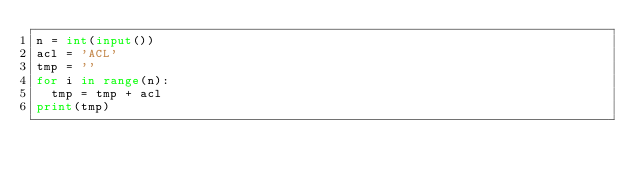Convert code to text. <code><loc_0><loc_0><loc_500><loc_500><_Python_>n = int(input())
acl = 'ACL'
tmp = ''
for i in range(n):
  tmp = tmp + acl
print(tmp)</code> 